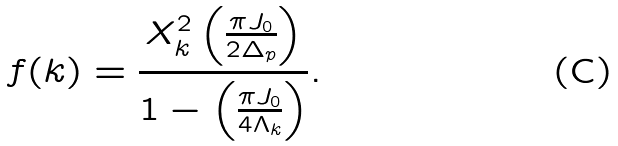<formula> <loc_0><loc_0><loc_500><loc_500>f ( k ) = \frac { X _ { k } ^ { 2 } \left ( \frac { \pi J _ { 0 } } { 2 \Delta _ { p } } \right ) } { 1 - \left ( \frac { \pi J _ { 0 } } { 4 \Lambda _ { k } } \right ) } .</formula> 